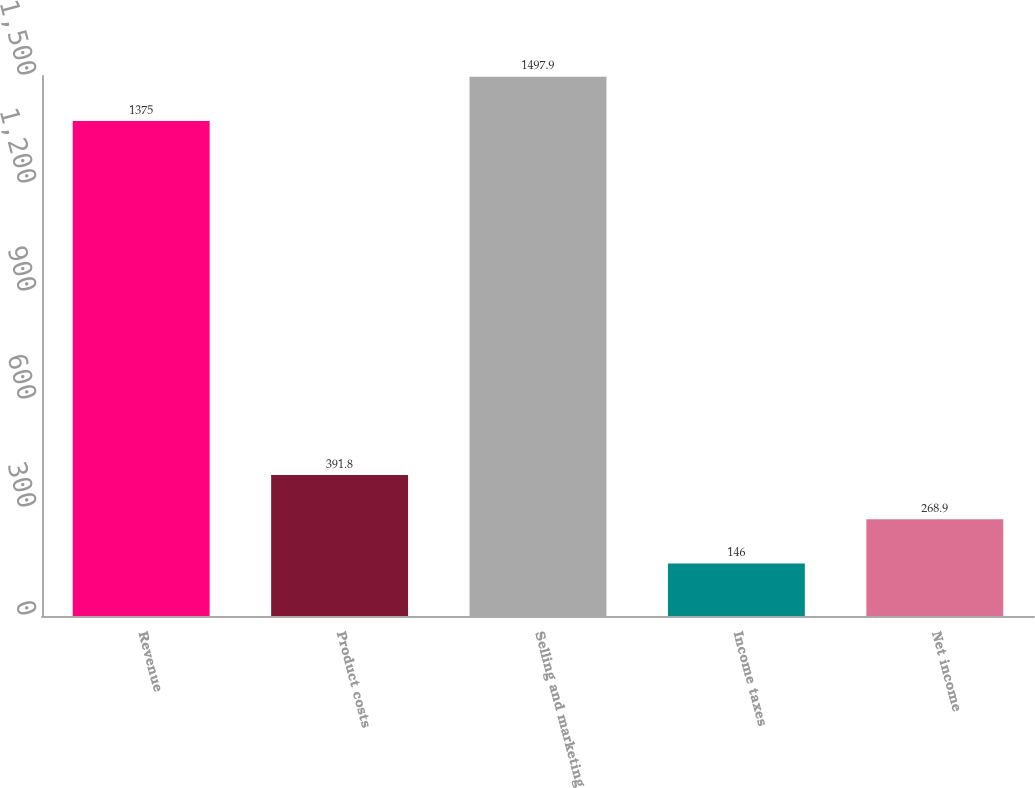<chart> <loc_0><loc_0><loc_500><loc_500><bar_chart><fcel>Revenue<fcel>Product costs<fcel>Selling and marketing<fcel>Income taxes<fcel>Net income<nl><fcel>1375<fcel>391.8<fcel>1497.9<fcel>146<fcel>268.9<nl></chart> 